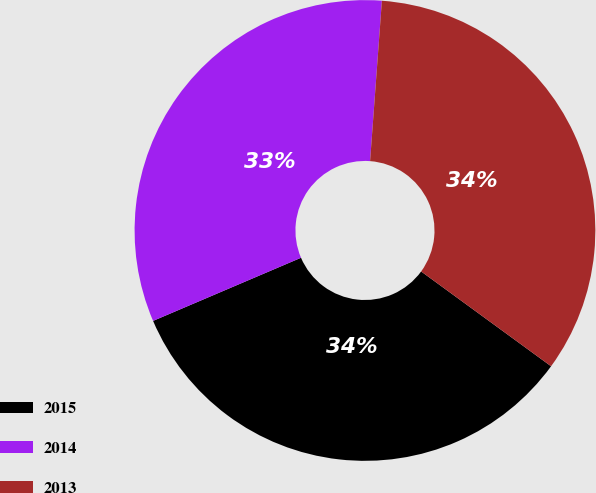Convert chart to OTSL. <chart><loc_0><loc_0><loc_500><loc_500><pie_chart><fcel>2015<fcel>2014<fcel>2013<nl><fcel>33.55%<fcel>32.59%<fcel>33.86%<nl></chart> 